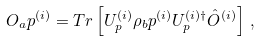Convert formula to latex. <formula><loc_0><loc_0><loc_500><loc_500>O _ { a } p ^ { ( i ) } = T r \left [ U _ { p } ^ { ( i ) } \rho _ { b } p ^ { ( i ) } U _ { p } ^ { ( i ) \dagger } \hat { O } ^ { ( i ) } \right ] \, ,</formula> 